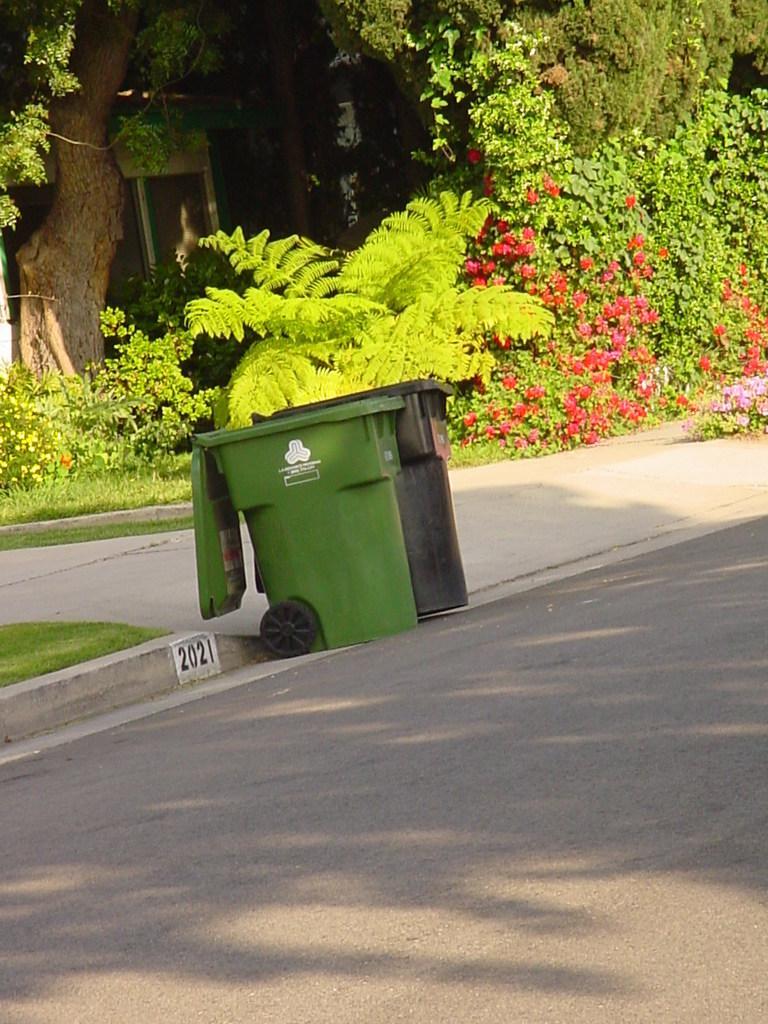In one or two sentences, can you explain what this image depicts? In the foreground of the image we can see two trash cans placed on the road. In the background we can see group of plants ,building and a tree. 